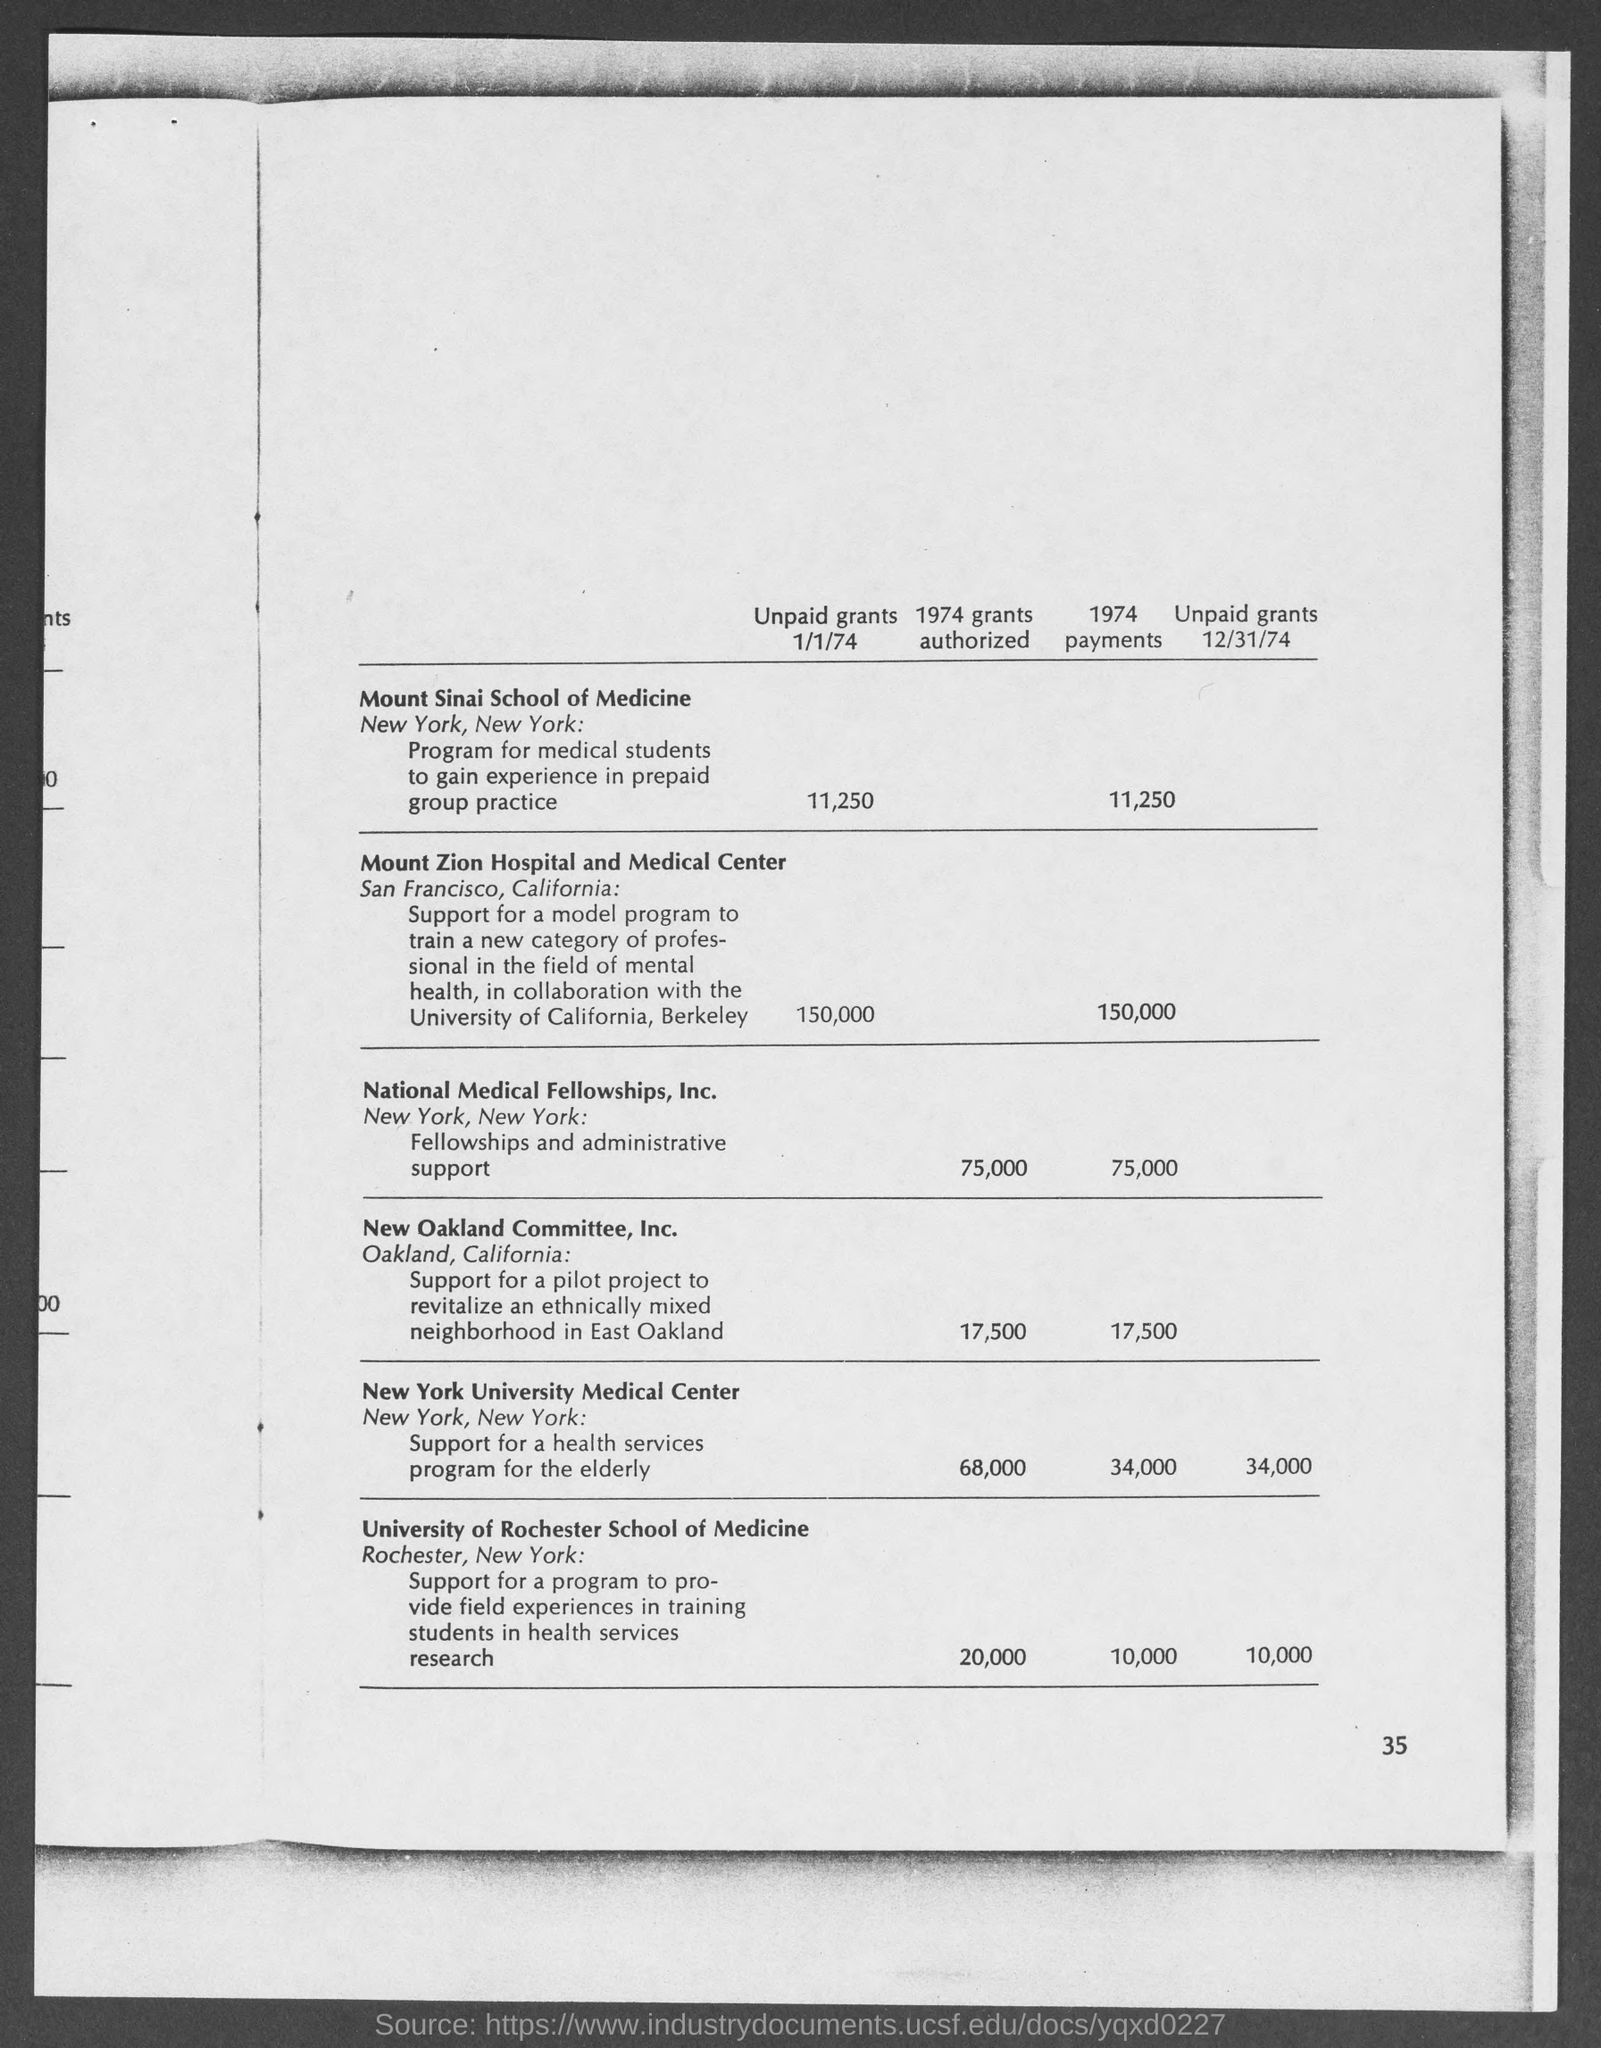How much is the unpaid grants as on 1/1/74 of mount sinai school of medicine?
Give a very brief answer. 11,250. 